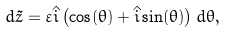Convert formula to latex. <formula><loc_0><loc_0><loc_500><loc_500>d \tilde { z } = \varepsilon \hat { i } \left ( \cos ( \theta ) + \hat { i } \sin ( \theta ) \right ) d \theta ,</formula> 